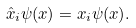<formula> <loc_0><loc_0><loc_500><loc_500>\hat { x } _ { i } \psi ( x ) = x _ { i } \psi ( x ) .</formula> 